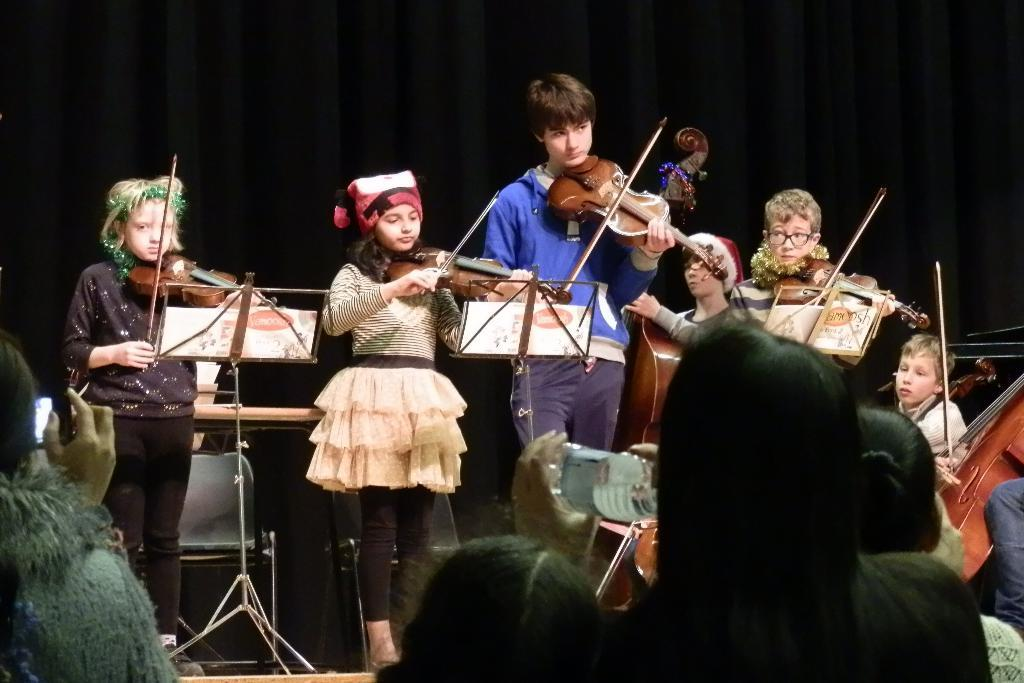What is happening on the stage in the image? There are people on a stage, and they are performing. What are the people on the stage doing during their performance? The people are playing musical instruments. Can you see any goldfish swimming in the background of the image? There are no goldfish present in the image. What type of twig is being used as a prop by the performers on the stage? There is no twig visible in the image; the performers are playing musical instruments. 